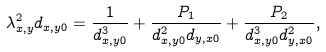Convert formula to latex. <formula><loc_0><loc_0><loc_500><loc_500>\lambda _ { x , y } ^ { 2 } d _ { x , y 0 } = \frac { 1 } { d _ { x , y 0 } ^ { 3 } } + \frac { P _ { 1 } } { d _ { x , y 0 } ^ { 2 } d _ { y , x 0 } } + \frac { P _ { 2 } } { d _ { x , y 0 } ^ { 3 } d _ { y , x 0 } ^ { 2 } } ,</formula> 